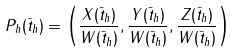Convert formula to latex. <formula><loc_0><loc_0><loc_500><loc_500>P _ { h } ( \bar { t } _ { h } ) = \left ( \frac { X ( \bar { t } _ { h } ) } { W ( \bar { t } _ { h } ) } , \frac { Y ( \bar { t } _ { h } ) } { W ( \bar { t } _ { h } ) } , \frac { Z ( \bar { t } _ { h } ) } { W ( \bar { t } _ { h } ) } \right )</formula> 